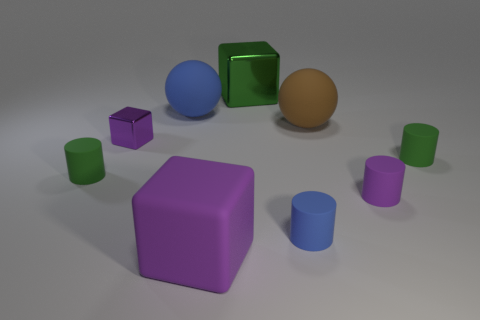Subtract all purple cubes. How many cubes are left? 1 Subtract all blue cylinders. How many purple blocks are left? 2 Subtract all purple cylinders. How many cylinders are left? 3 Subtract 1 blocks. How many blocks are left? 2 Add 1 red metal objects. How many objects exist? 10 Subtract all cyan cylinders. Subtract all gray balls. How many cylinders are left? 4 Subtract all cubes. How many objects are left? 6 Subtract all red things. Subtract all large things. How many objects are left? 5 Add 5 large green shiny things. How many large green shiny things are left? 6 Add 3 big purple matte objects. How many big purple matte objects exist? 4 